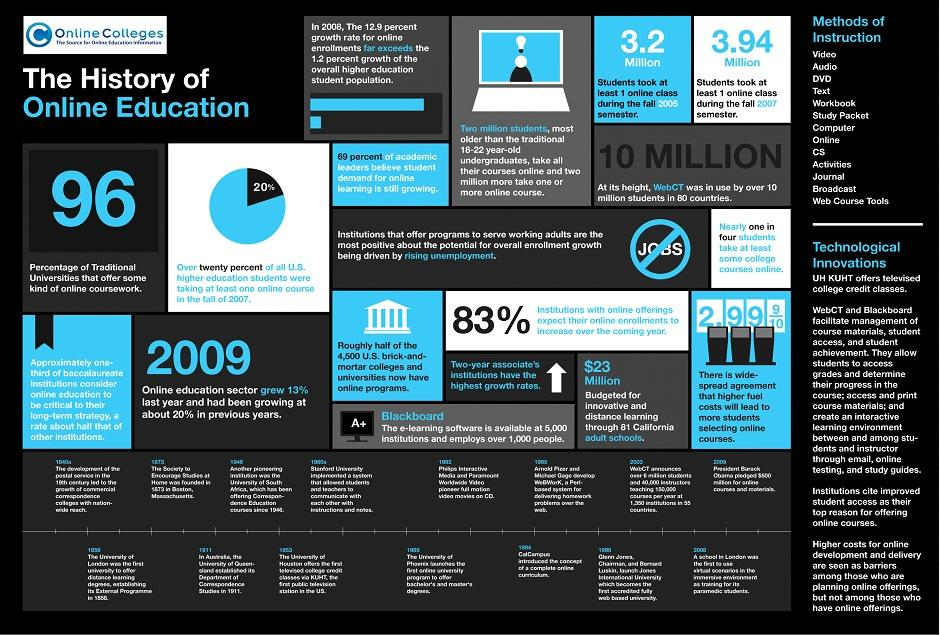Give some essential details in this illustration. The number of methods of instructions is 13. According to recent statistics, 96% of traditional universities offer online coursework. 